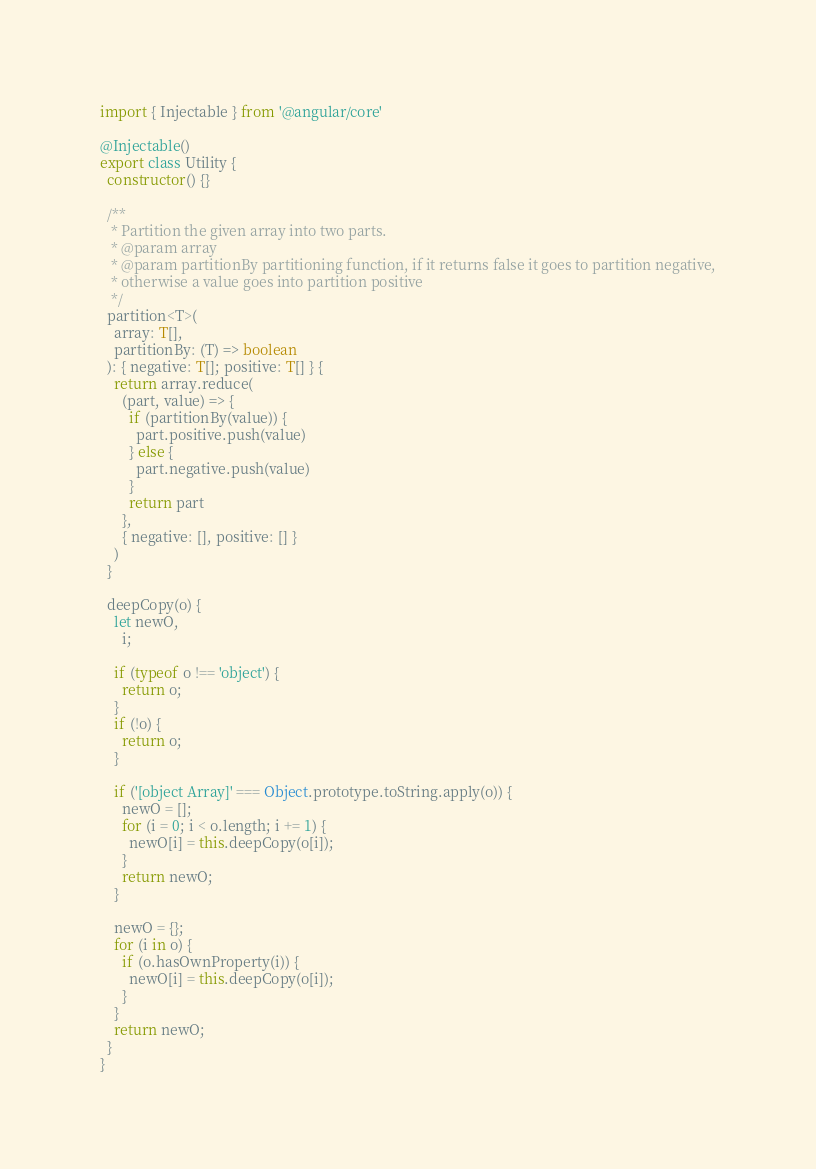<code> <loc_0><loc_0><loc_500><loc_500><_TypeScript_>import { Injectable } from '@angular/core'

@Injectable()
export class Utility {
  constructor() {}

  /**
   * Partition the given array into two parts.
   * @param array
   * @param partitionBy partitioning function, if it returns false it goes to partition negative,
   * otherwise a value goes into partition positive
   */
  partition<T>(
    array: T[],
    partitionBy: (T) => boolean
  ): { negative: T[]; positive: T[] } {
    return array.reduce(
      (part, value) => {
        if (partitionBy(value)) {
          part.positive.push(value)
        } else {
          part.negative.push(value)
        }
        return part
      },
      { negative: [], positive: [] }
    )
  }

  deepCopy(o) {
    let newO,
      i;

    if (typeof o !== 'object') {
      return o;
    }
    if (!o) {
      return o;
    }

    if ('[object Array]' === Object.prototype.toString.apply(o)) {
      newO = [];
      for (i = 0; i < o.length; i += 1) {
        newO[i] = this.deepCopy(o[i]);
      }
      return newO;
    }

    newO = {};
    for (i in o) {
      if (o.hasOwnProperty(i)) {
        newO[i] = this.deepCopy(o[i]);
      }
    }
    return newO;
  }
}
</code> 